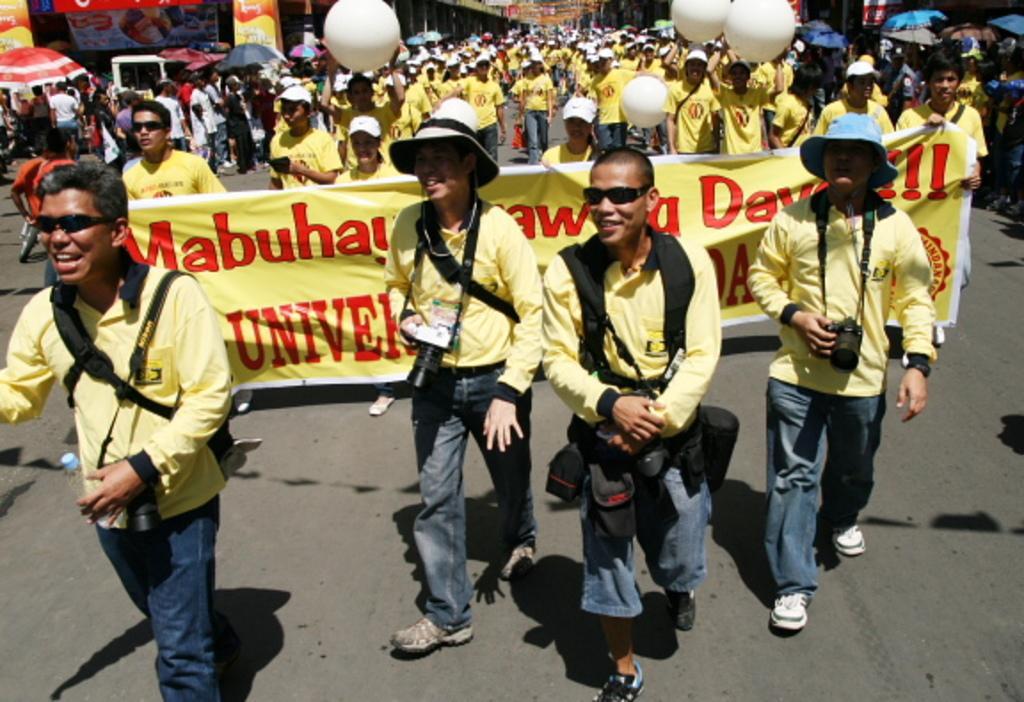Please provide a concise description of this image. In the foreground we can see four men walking on the road. They are wearing the similar dressing style and they are smiling. Here we can see two men carrying the camera in their hands. Here we can see the bags on their backs. In the background, we can see a group of people walking on the road. Here we can see the caps on their heads. Here we can see the banner. Here we can see the umbrellas. 